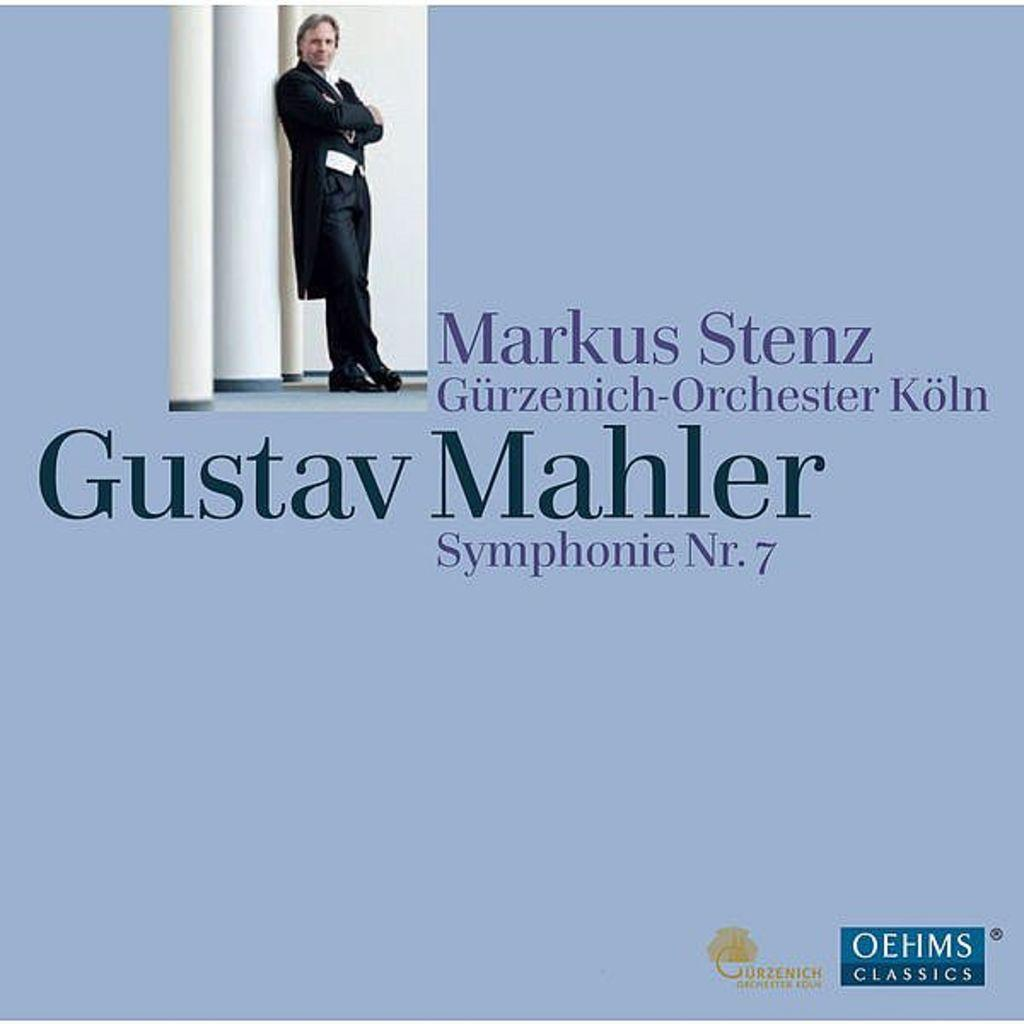What type of publication is the image from? The image is the cover page of a magazine. Who is featured on the cover of the magazine? There is a person's picture on the cover. What color is the background of the magazine cover? The background of the cover is purple. Are there any names mentioned on the cover of the magazine? Yes, there are names mentioned on the cover. What pocket is the person on the cover reaching into in the image? There is no pocket visible in the image, nor is the person reaching into one. 